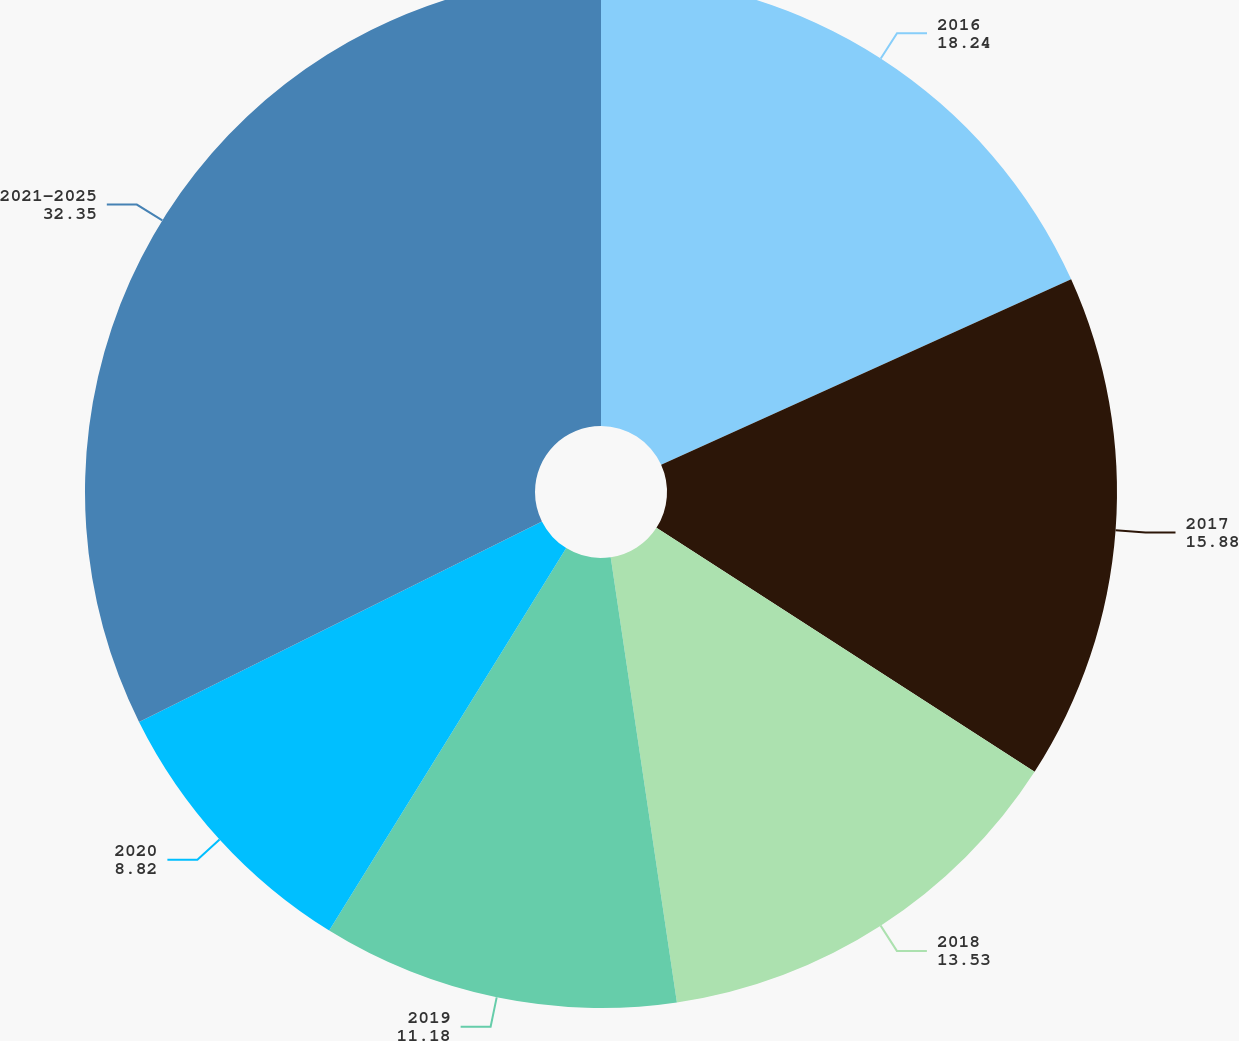<chart> <loc_0><loc_0><loc_500><loc_500><pie_chart><fcel>2016<fcel>2017<fcel>2018<fcel>2019<fcel>2020<fcel>2021-2025<nl><fcel>18.24%<fcel>15.88%<fcel>13.53%<fcel>11.18%<fcel>8.82%<fcel>32.35%<nl></chart> 